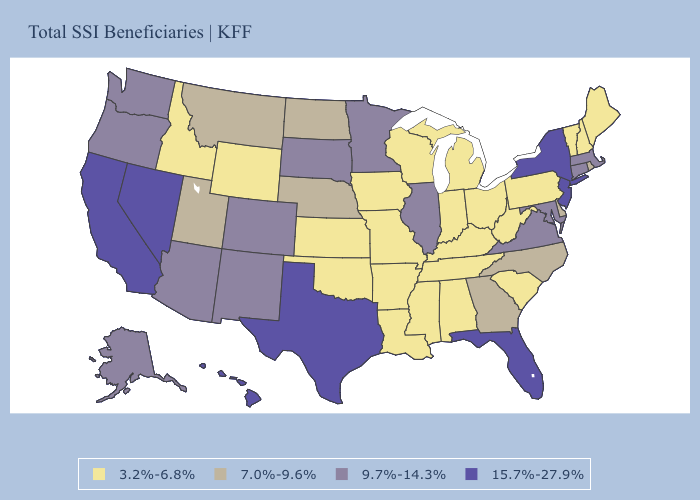What is the value of Kentucky?
Write a very short answer. 3.2%-6.8%. What is the lowest value in the Northeast?
Concise answer only. 3.2%-6.8%. Does the map have missing data?
Write a very short answer. No. Does the map have missing data?
Keep it brief. No. Does the map have missing data?
Be succinct. No. Name the states that have a value in the range 7.0%-9.6%?
Short answer required. Delaware, Georgia, Montana, Nebraska, North Carolina, North Dakota, Rhode Island, Utah. What is the value of Wyoming?
Quick response, please. 3.2%-6.8%. Name the states that have a value in the range 7.0%-9.6%?
Write a very short answer. Delaware, Georgia, Montana, Nebraska, North Carolina, North Dakota, Rhode Island, Utah. Which states hav the highest value in the South?
Be succinct. Florida, Texas. Does Rhode Island have the lowest value in the Northeast?
Be succinct. No. Does the first symbol in the legend represent the smallest category?
Give a very brief answer. Yes. Does Rhode Island have the lowest value in the Northeast?
Give a very brief answer. No. Which states have the lowest value in the USA?
Concise answer only. Alabama, Arkansas, Idaho, Indiana, Iowa, Kansas, Kentucky, Louisiana, Maine, Michigan, Mississippi, Missouri, New Hampshire, Ohio, Oklahoma, Pennsylvania, South Carolina, Tennessee, Vermont, West Virginia, Wisconsin, Wyoming. Does Kansas have the highest value in the MidWest?
Keep it brief. No. Does Pennsylvania have a lower value than Mississippi?
Give a very brief answer. No. 